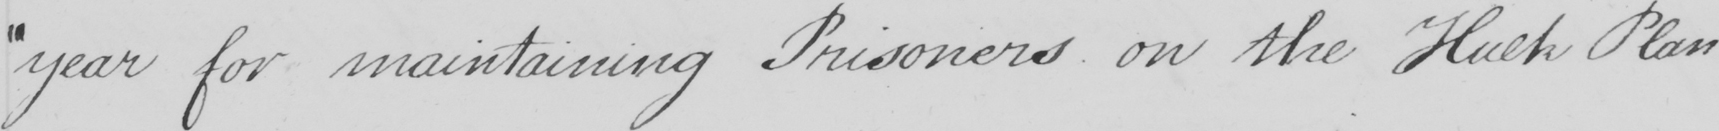Please provide the text content of this handwritten line. " year for maintaining Prisoners on the Hulk Plan _ 